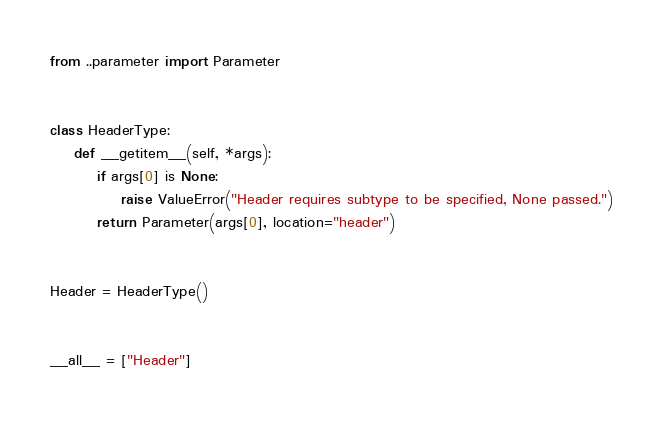<code> <loc_0><loc_0><loc_500><loc_500><_Python_>from ..parameter import Parameter


class HeaderType:
    def __getitem__(self, *args):
        if args[0] is None:
            raise ValueError("Header requires subtype to be specified, None passed.")
        return Parameter(args[0], location="header")


Header = HeaderType()


__all__ = ["Header"]
</code> 